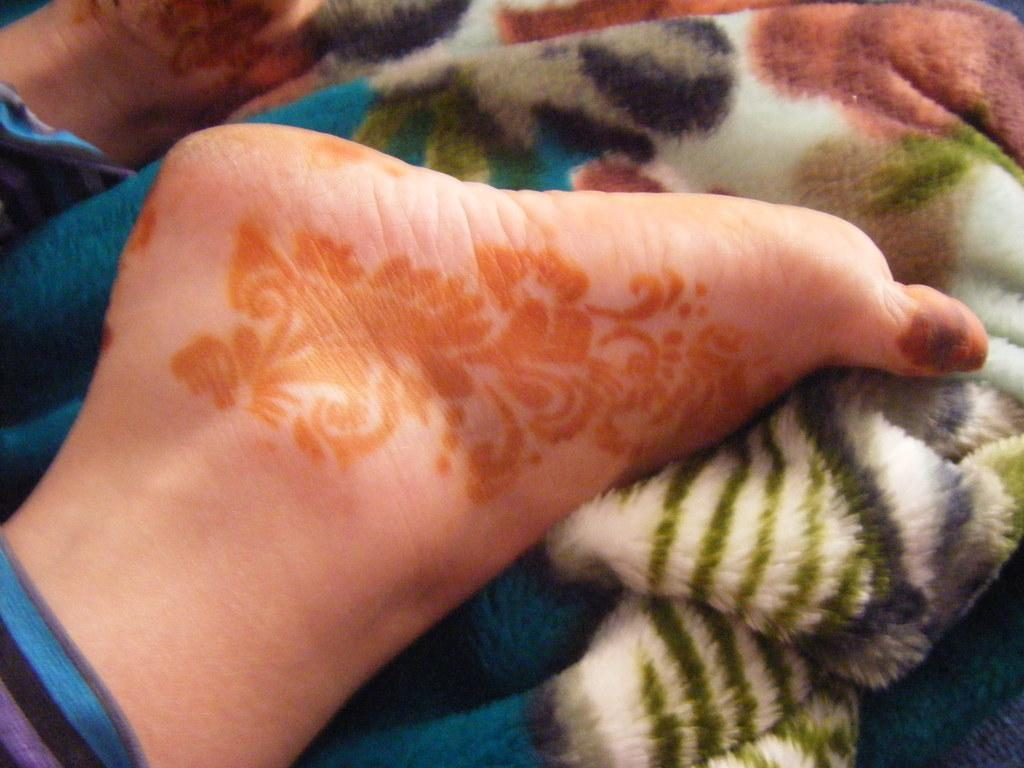What body part of a person is visible in the image? There are a person's legs visible in the image. What object is present in the image along with the person's legs? There is a blanket in the image. What songs are being sung by the characters in the image? There are no characters or songs present in the image; it only shows a person's legs and a blanket. 